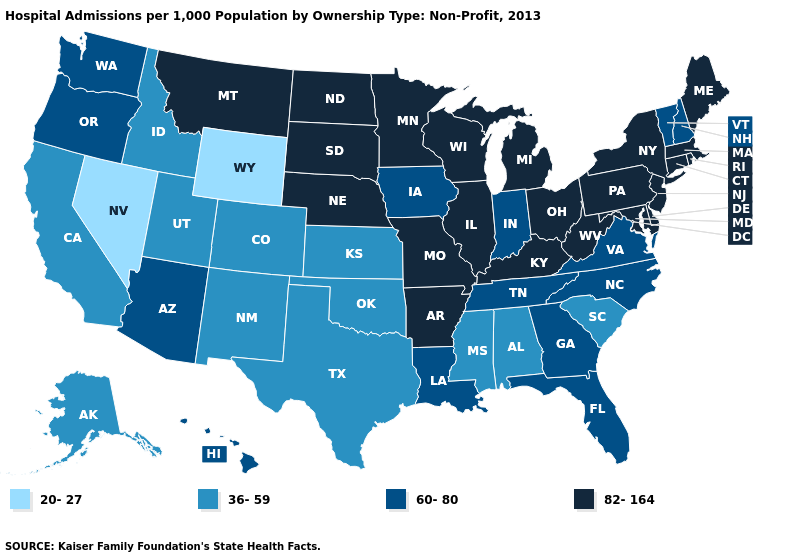Does Massachusetts have the highest value in the USA?
Quick response, please. Yes. Does Wyoming have the lowest value in the USA?
Give a very brief answer. Yes. What is the lowest value in the MidWest?
Quick response, please. 36-59. Among the states that border Arkansas , does Louisiana have the highest value?
Quick response, please. No. Name the states that have a value in the range 36-59?
Write a very short answer. Alabama, Alaska, California, Colorado, Idaho, Kansas, Mississippi, New Mexico, Oklahoma, South Carolina, Texas, Utah. Name the states that have a value in the range 82-164?
Give a very brief answer. Arkansas, Connecticut, Delaware, Illinois, Kentucky, Maine, Maryland, Massachusetts, Michigan, Minnesota, Missouri, Montana, Nebraska, New Jersey, New York, North Dakota, Ohio, Pennsylvania, Rhode Island, South Dakota, West Virginia, Wisconsin. Among the states that border South Dakota , does Iowa have the highest value?
Answer briefly. No. Name the states that have a value in the range 20-27?
Be succinct. Nevada, Wyoming. What is the value of South Dakota?
Write a very short answer. 82-164. What is the highest value in states that border Nebraska?
Be succinct. 82-164. What is the lowest value in states that border Mississippi?
Answer briefly. 36-59. What is the value of Louisiana?
Quick response, please. 60-80. Name the states that have a value in the range 82-164?
Be succinct. Arkansas, Connecticut, Delaware, Illinois, Kentucky, Maine, Maryland, Massachusetts, Michigan, Minnesota, Missouri, Montana, Nebraska, New Jersey, New York, North Dakota, Ohio, Pennsylvania, Rhode Island, South Dakota, West Virginia, Wisconsin. Which states have the lowest value in the USA?
Answer briefly. Nevada, Wyoming. What is the value of Nevada?
Quick response, please. 20-27. 